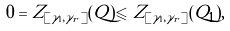Convert formula to latex. <formula><loc_0><loc_0><loc_500><loc_500>0 = Z _ { [ \gamma _ { 1 } , \gamma _ { r } ] } ( Q ) \leqslant Z _ { [ \gamma _ { 1 } , \gamma _ { r } ] } ( Q _ { 1 } ) ,</formula> 